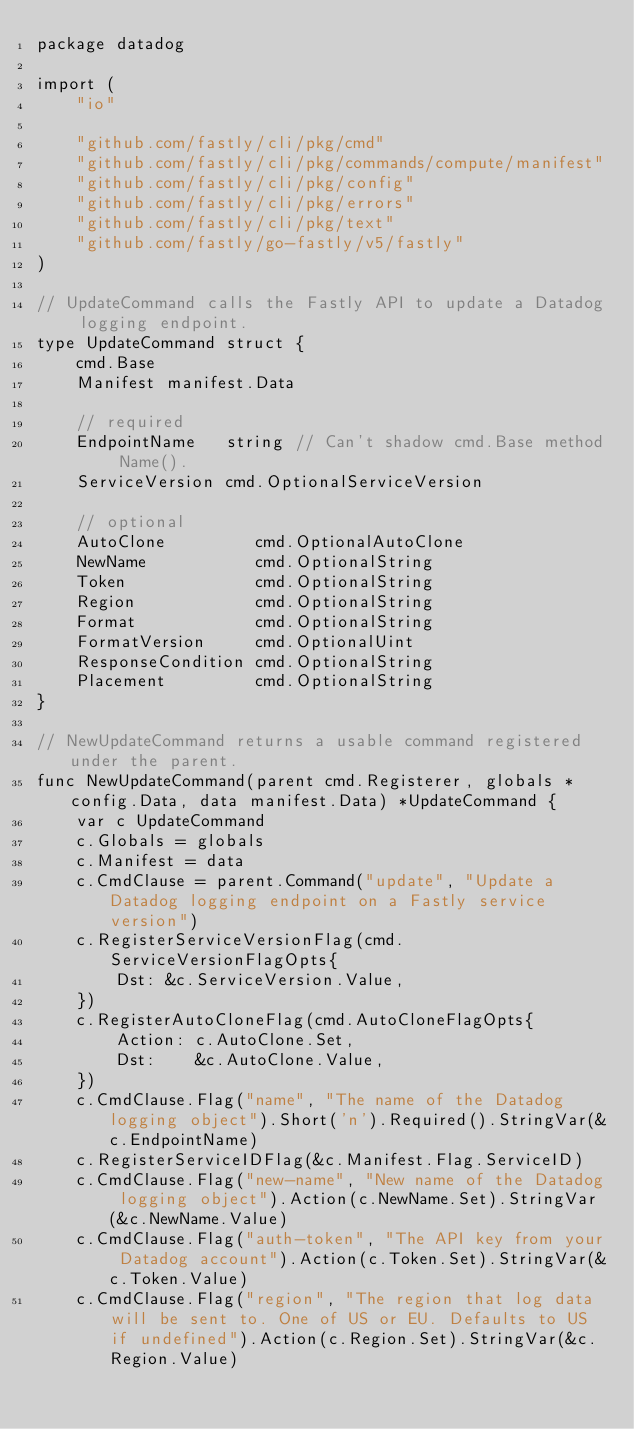Convert code to text. <code><loc_0><loc_0><loc_500><loc_500><_Go_>package datadog

import (
	"io"

	"github.com/fastly/cli/pkg/cmd"
	"github.com/fastly/cli/pkg/commands/compute/manifest"
	"github.com/fastly/cli/pkg/config"
	"github.com/fastly/cli/pkg/errors"
	"github.com/fastly/cli/pkg/text"
	"github.com/fastly/go-fastly/v5/fastly"
)

// UpdateCommand calls the Fastly API to update a Datadog logging endpoint.
type UpdateCommand struct {
	cmd.Base
	Manifest manifest.Data

	// required
	EndpointName   string // Can't shadow cmd.Base method Name().
	ServiceVersion cmd.OptionalServiceVersion

	// optional
	AutoClone         cmd.OptionalAutoClone
	NewName           cmd.OptionalString
	Token             cmd.OptionalString
	Region            cmd.OptionalString
	Format            cmd.OptionalString
	FormatVersion     cmd.OptionalUint
	ResponseCondition cmd.OptionalString
	Placement         cmd.OptionalString
}

// NewUpdateCommand returns a usable command registered under the parent.
func NewUpdateCommand(parent cmd.Registerer, globals *config.Data, data manifest.Data) *UpdateCommand {
	var c UpdateCommand
	c.Globals = globals
	c.Manifest = data
	c.CmdClause = parent.Command("update", "Update a Datadog logging endpoint on a Fastly service version")
	c.RegisterServiceVersionFlag(cmd.ServiceVersionFlagOpts{
		Dst: &c.ServiceVersion.Value,
	})
	c.RegisterAutoCloneFlag(cmd.AutoCloneFlagOpts{
		Action: c.AutoClone.Set,
		Dst:    &c.AutoClone.Value,
	})
	c.CmdClause.Flag("name", "The name of the Datadog logging object").Short('n').Required().StringVar(&c.EndpointName)
	c.RegisterServiceIDFlag(&c.Manifest.Flag.ServiceID)
	c.CmdClause.Flag("new-name", "New name of the Datadog logging object").Action(c.NewName.Set).StringVar(&c.NewName.Value)
	c.CmdClause.Flag("auth-token", "The API key from your Datadog account").Action(c.Token.Set).StringVar(&c.Token.Value)
	c.CmdClause.Flag("region", "The region that log data will be sent to. One of US or EU. Defaults to US if undefined").Action(c.Region.Set).StringVar(&c.Region.Value)</code> 